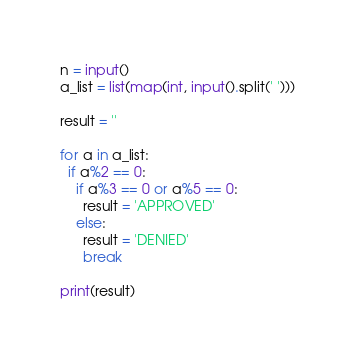Convert code to text. <code><loc_0><loc_0><loc_500><loc_500><_Python_>n = input()
a_list = list(map(int, input().split(' ')))

result = ''

for a in a_list:
  if a%2 == 0:
    if a%3 == 0 or a%5 == 0:
      result = 'APPROVED'
    else:
      result = 'DENIED'
      break

print(result)</code> 